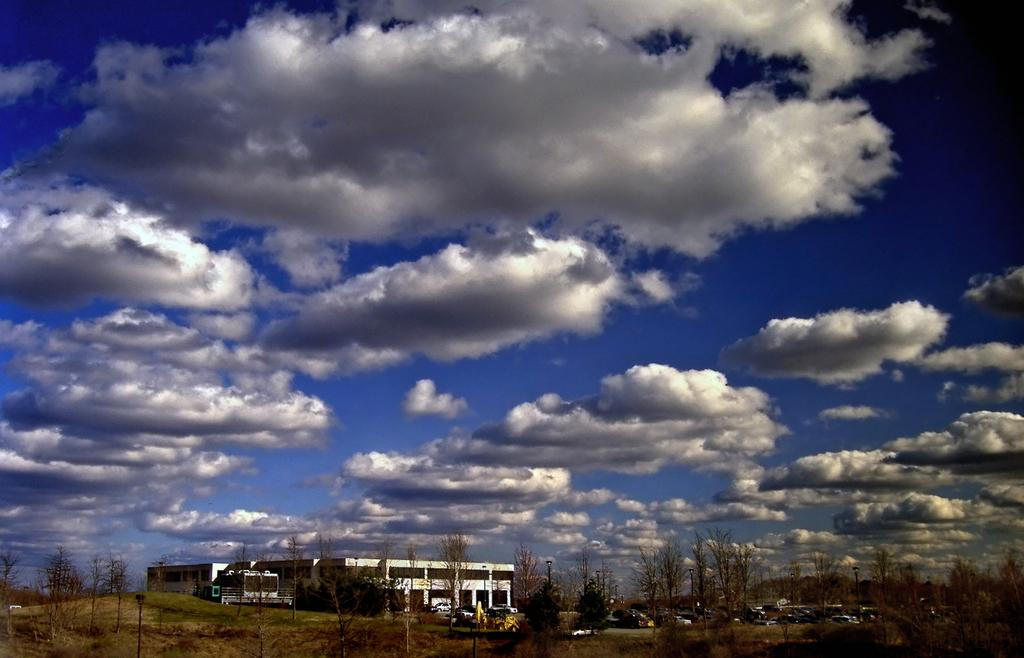What is located at the bottom of the image? There is a building, trees, and vehicles at the bottom of the image. What type of vegetation is present at the bottom of the image? Grass is visible at the bottom of the image. What can be seen in the background of the image? The sky and clouds are present in the background of the image. What type of skirt is the goose wearing in the image? There is no goose or skirt present in the image. How many cows are visible in the image? There are no cows present in the image. 